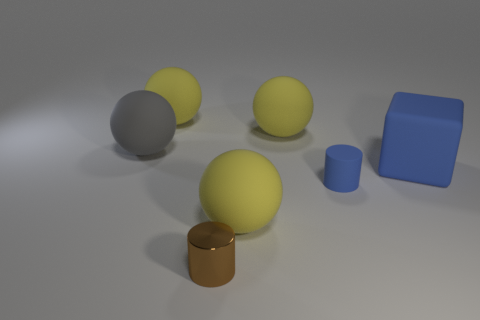Subtract all yellow spheres. How many were subtracted if there are1yellow spheres left? 2 Subtract all big gray matte spheres. How many spheres are left? 3 Subtract all yellow cubes. How many yellow spheres are left? 3 Subtract all gray balls. How many balls are left? 3 Add 2 blue cubes. How many objects exist? 9 Subtract all spheres. How many objects are left? 3 Subtract 2 spheres. How many spheres are left? 2 Subtract all big objects. Subtract all small red metal things. How many objects are left? 2 Add 6 rubber cubes. How many rubber cubes are left? 7 Add 5 gray balls. How many gray balls exist? 6 